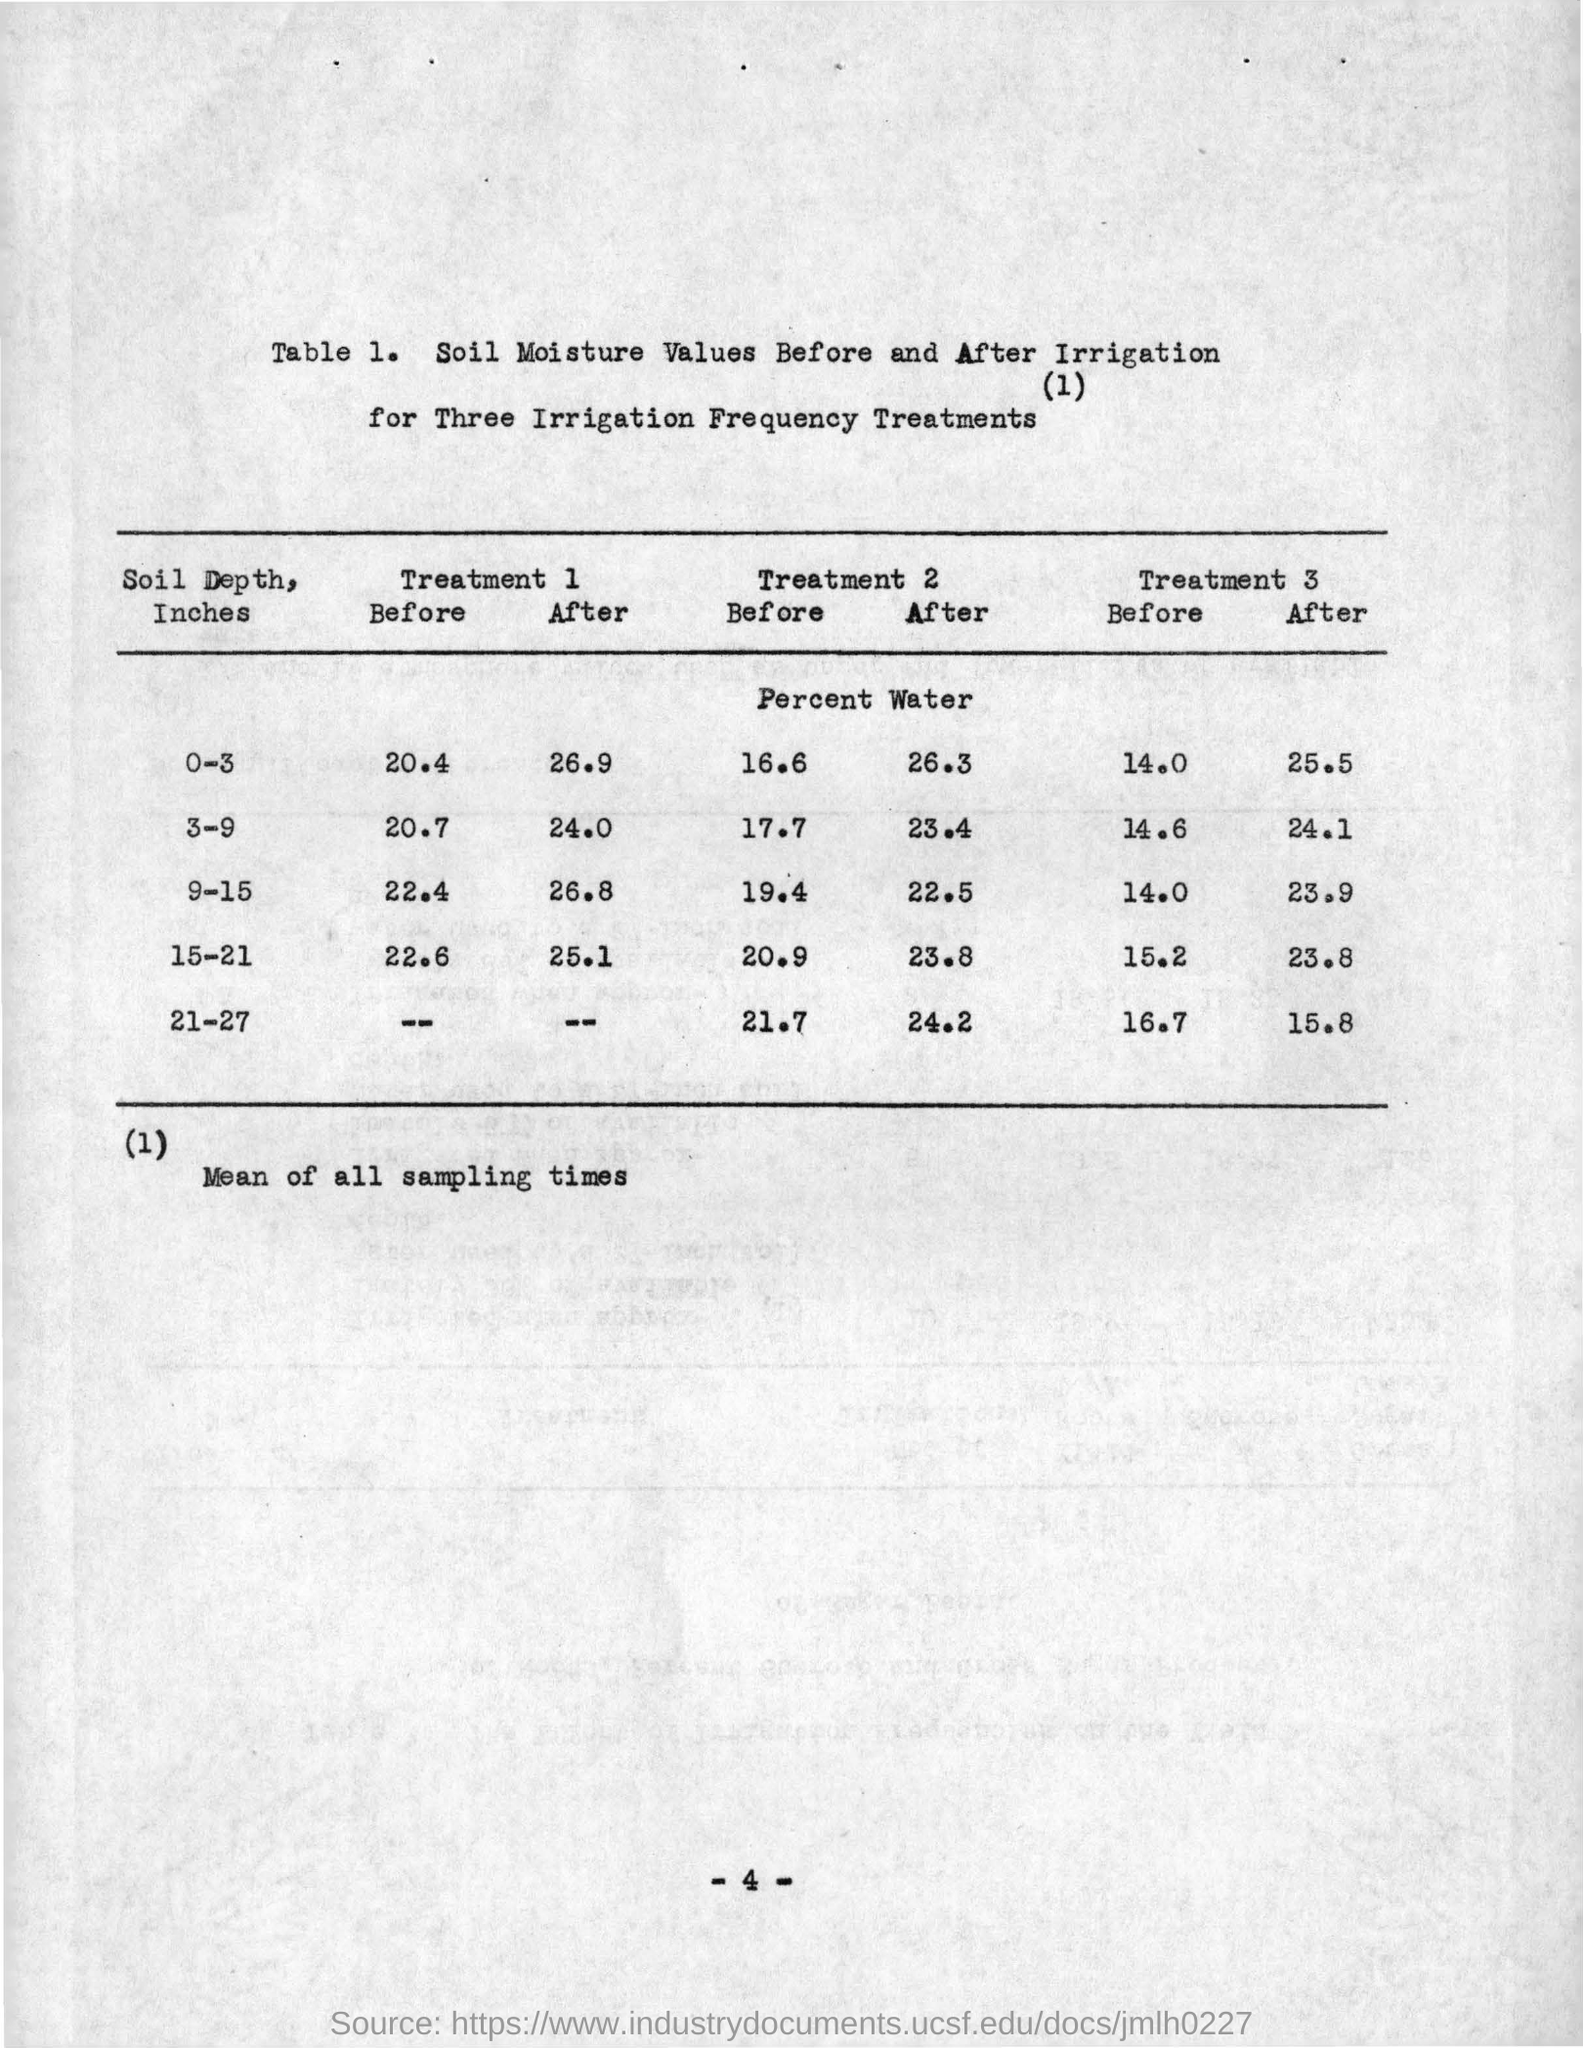What is table number written in the document ?
Your answer should be very brief. 1. What is point (1) written below the table?
Give a very brief answer. Mean of all sampling times. 